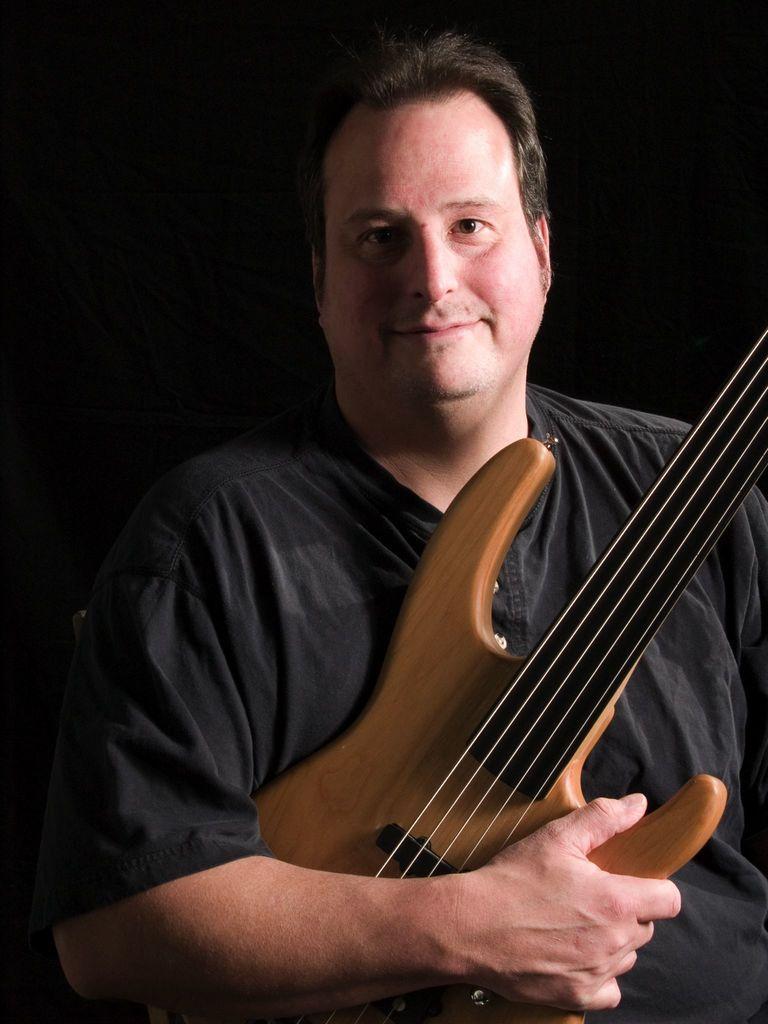Describe this image in one or two sentences. In the picture we can see a man holding a guitar, which is brown in color and with strings, a man is wearing a black shirt, in the background there is black color. 